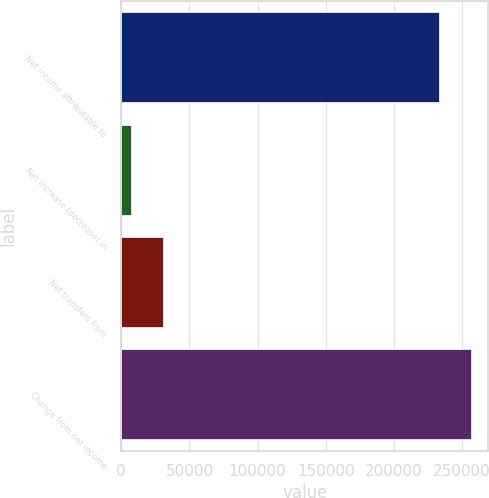Convert chart to OTSL. <chart><loc_0><loc_0><loc_500><loc_500><bar_chart><fcel>Net income attributable to<fcel>Net increase (decrease) in<fcel>Net transfers from<fcel>Change from net income<nl><fcel>232850<fcel>6928<fcel>30213<fcel>256135<nl></chart> 